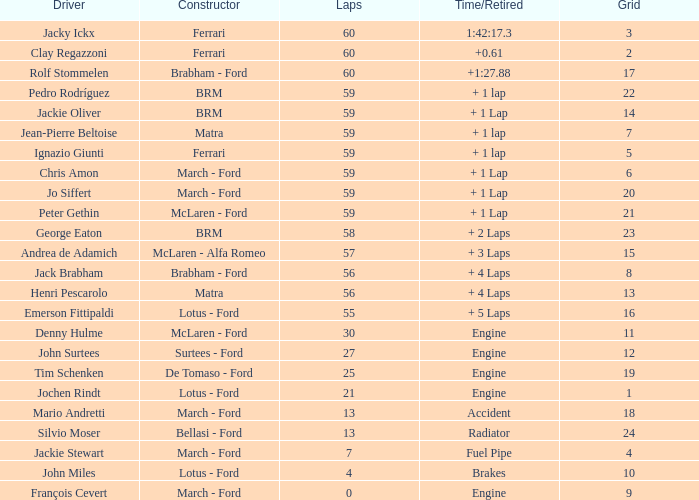I am looking for the driver for a 9-square grid. François Cevert. 